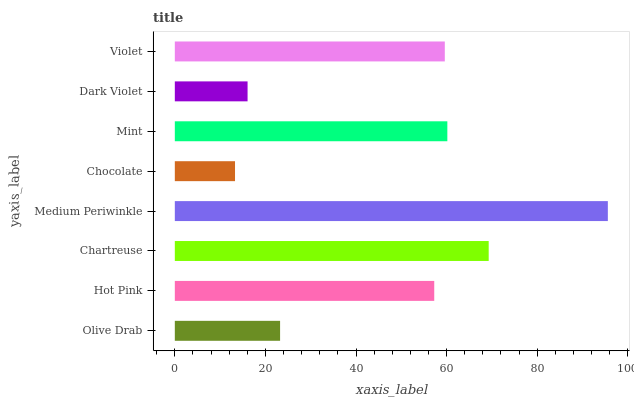Is Chocolate the minimum?
Answer yes or no. Yes. Is Medium Periwinkle the maximum?
Answer yes or no. Yes. Is Hot Pink the minimum?
Answer yes or no. No. Is Hot Pink the maximum?
Answer yes or no. No. Is Hot Pink greater than Olive Drab?
Answer yes or no. Yes. Is Olive Drab less than Hot Pink?
Answer yes or no. Yes. Is Olive Drab greater than Hot Pink?
Answer yes or no. No. Is Hot Pink less than Olive Drab?
Answer yes or no. No. Is Violet the high median?
Answer yes or no. Yes. Is Hot Pink the low median?
Answer yes or no. Yes. Is Dark Violet the high median?
Answer yes or no. No. Is Dark Violet the low median?
Answer yes or no. No. 